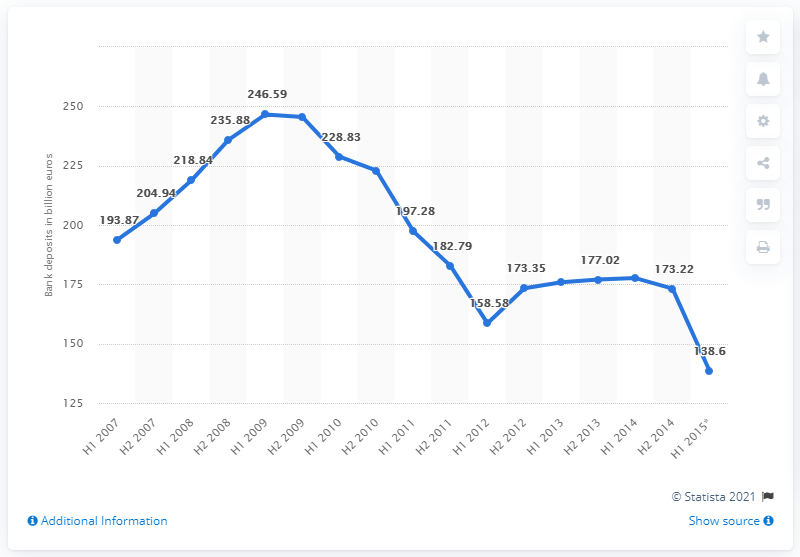List a handful of essential elements in this visual. The total value of Greek bank deposits in 2009 was approximately 245.47. In 2015, the total value of Greek bank deposits was 138.6 billion euros. 